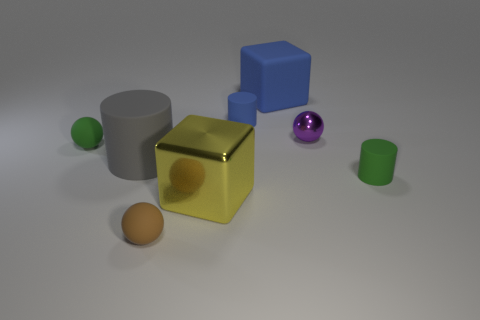There is a thing that is the same color as the matte block; what size is it?
Offer a terse response. Small. There is a large rubber cylinder; is its color the same as the metal object that is to the right of the yellow shiny object?
Keep it short and to the point. No. What number of tiny matte cylinders have the same color as the large matte block?
Ensure brevity in your answer.  1. The large rubber cube has what color?
Your answer should be compact. Blue. Do the cylinder that is behind the green matte ball and the green thing left of the green rubber cylinder have the same size?
Provide a short and direct response. Yes. Are there any blue rubber things of the same shape as the large metallic object?
Your answer should be compact. Yes. Are there fewer large blue rubber cubes in front of the blue block than cyan shiny things?
Ensure brevity in your answer.  No. Is the shape of the big blue thing the same as the big yellow shiny thing?
Your answer should be compact. Yes. What size is the green object that is on the left side of the blue block?
Your answer should be very brief. Small. There is a blue cylinder that is the same material as the big blue block; what is its size?
Provide a succinct answer. Small. 